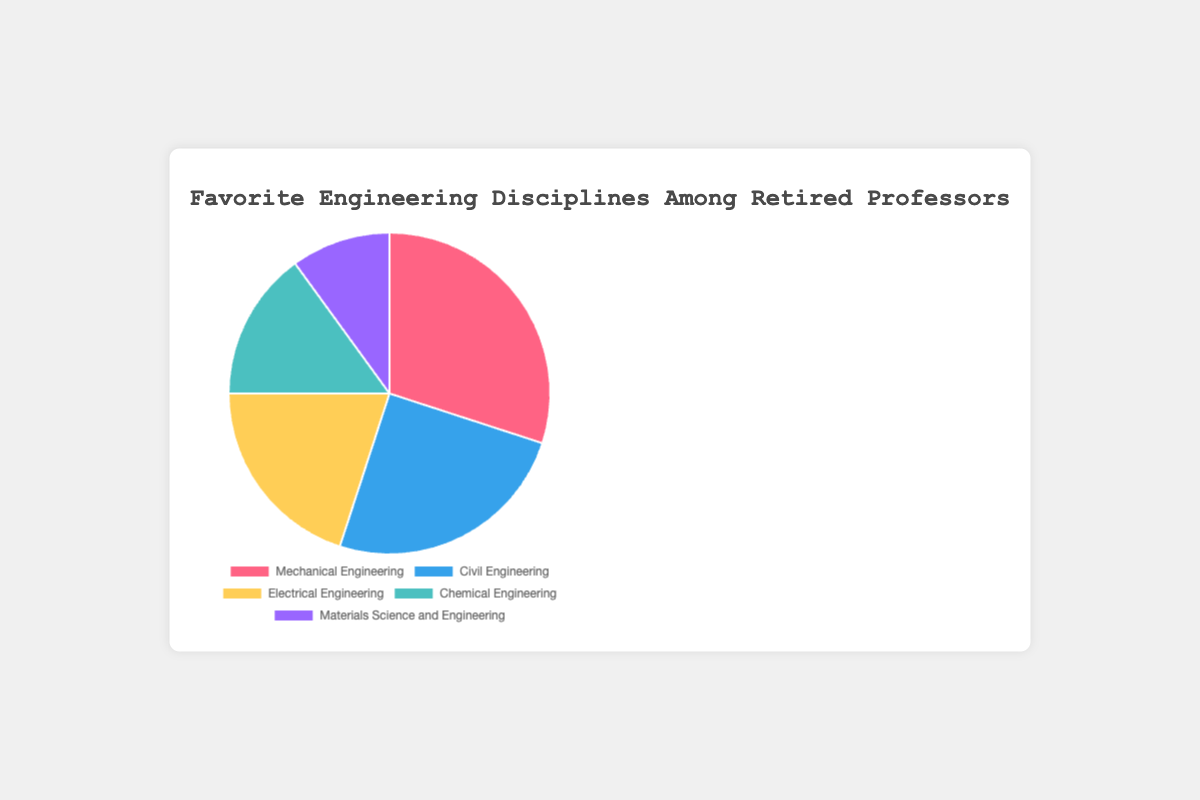Which engineering discipline is the most favored among retired professors? The largest section of the pie chart represents the most favored engineering discipline. To determine which discipline this is, look for the section with the highest percentage. The data shows that Mechanical Engineering is favored by 30% of retired professors.
Answer: Mechanical Engineering Which two engineering disciplines have the smallest percentage of favoritism combined? To find the disciplines with the smallest combined percentage, identify the two smallest slices of the pie chart and sum their percentages. The smallest slices are Materials Science and Engineering (10%) and Chemical Engineering (15%). Adding these, 10% + 15% = 25%.
Answer: Materials Science and Engineering and Chemical Engineering How much more favored is Mechanical Engineering compared to Electrical Engineering? Look at the percentages for each discipline in the pie chart. Mechanical Engineering is favored by 30%, and Electrical Engineering by 20%. Subtract the smaller percentage from the larger percentage: 30% - 20% = 10%.
Answer: 10% What is the combined percentage of favoritism for disciplines other than Mechanical Engineering? To find the combined percentage for all other disciplines, add up the percentages of Civil Engineering, Electrical Engineering, Chemical Engineering, and Materials Science and Engineering. These are 25%, 20%, 15%, and 10%, respectively. Summing them gives 25% + 20% + 15% + 10% = 70%.
Answer: 70% Which discipline is represented by the blue section in the pie chart? The color blue is associated with Civil Engineering in the given dataset. By examining the pie chart's legend, we see that Civil Engineering is represented by the blue section.
Answer: Civil Engineering Rank the engineering disciplines from most favored to least favored. Observing the pie chart's sections, the sizes represent the percentage of favoritism. The disciplines are given as Mechanical Engineering (30%), Civil Engineering (25%), Electrical Engineering (20%), Chemical Engineering (15%), and Materials Science and Engineering (10%). Rank them based on these percentages from highest to lowest.
Answer: Mechanical Engineering, Civil Engineering, Electrical Engineering, Chemical Engineering, Materials Science and Engineering If another discipline were added with a 10% favoritism, how would that affect the current rankings? Adding another discipline with 10% favoritism would mean that it shares the same percentage as Materials Science and Engineering. Since the current lowest percentage is 10% (Materials Science and Engineering), the new discipline would tie for the last place and every rank above would remain unchanged.
Answer: New discipline ties for last place with Materials Science and Engineering What percentage of retired professors favor Electrical or Chemical Engineering? To determine the combined percentage of Electrical and Chemical Engineering, add their individual percentages. Electrical Engineering is favored by 20%, and Chemical Engineering by 15%. Thus, the total is 20% + 15% = 35%.
Answer: 35% What is the visual color for the least favored discipline? The least favored discipline is Materials Science and Engineering with 10%. The corresponding color for Materials Science and Engineering in the pie chart is identified through the legend, which shows it as purple.
Answer: Purple Considering the data, what fraction of all professors have a favorite that is either Mechanical or Civil Engineering? The percentage of professors favoring Mechanical Engineering is 30%, and for Civil Engineering, it is 25%. Adding these percentages provides the total percentage: 30% + 25% = 55%. Thus, the fraction is 55/100, which simplifies to 11/20.
Answer: 11/20 